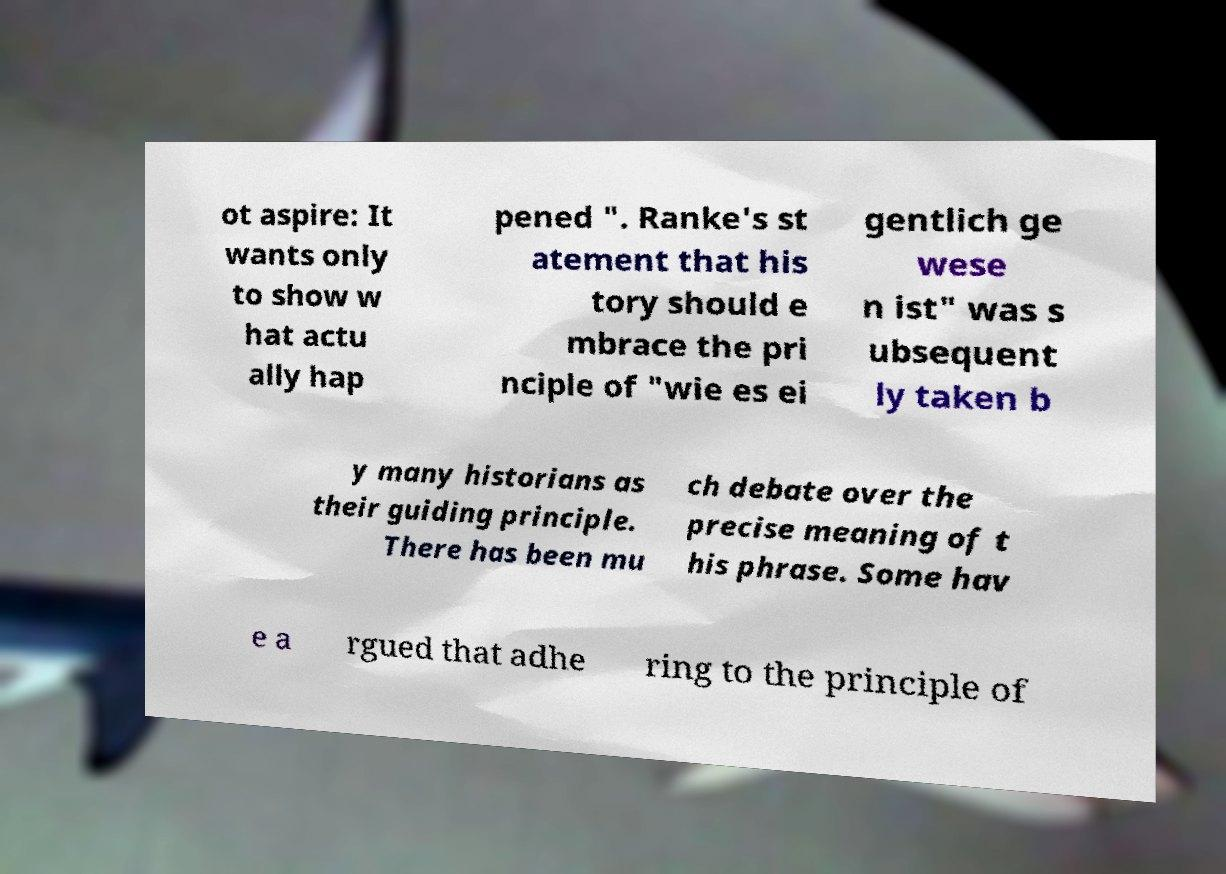There's text embedded in this image that I need extracted. Can you transcribe it verbatim? ot aspire: It wants only to show w hat actu ally hap pened ". Ranke's st atement that his tory should e mbrace the pri nciple of "wie es ei gentlich ge wese n ist" was s ubsequent ly taken b y many historians as their guiding principle. There has been mu ch debate over the precise meaning of t his phrase. Some hav e a rgued that adhe ring to the principle of 